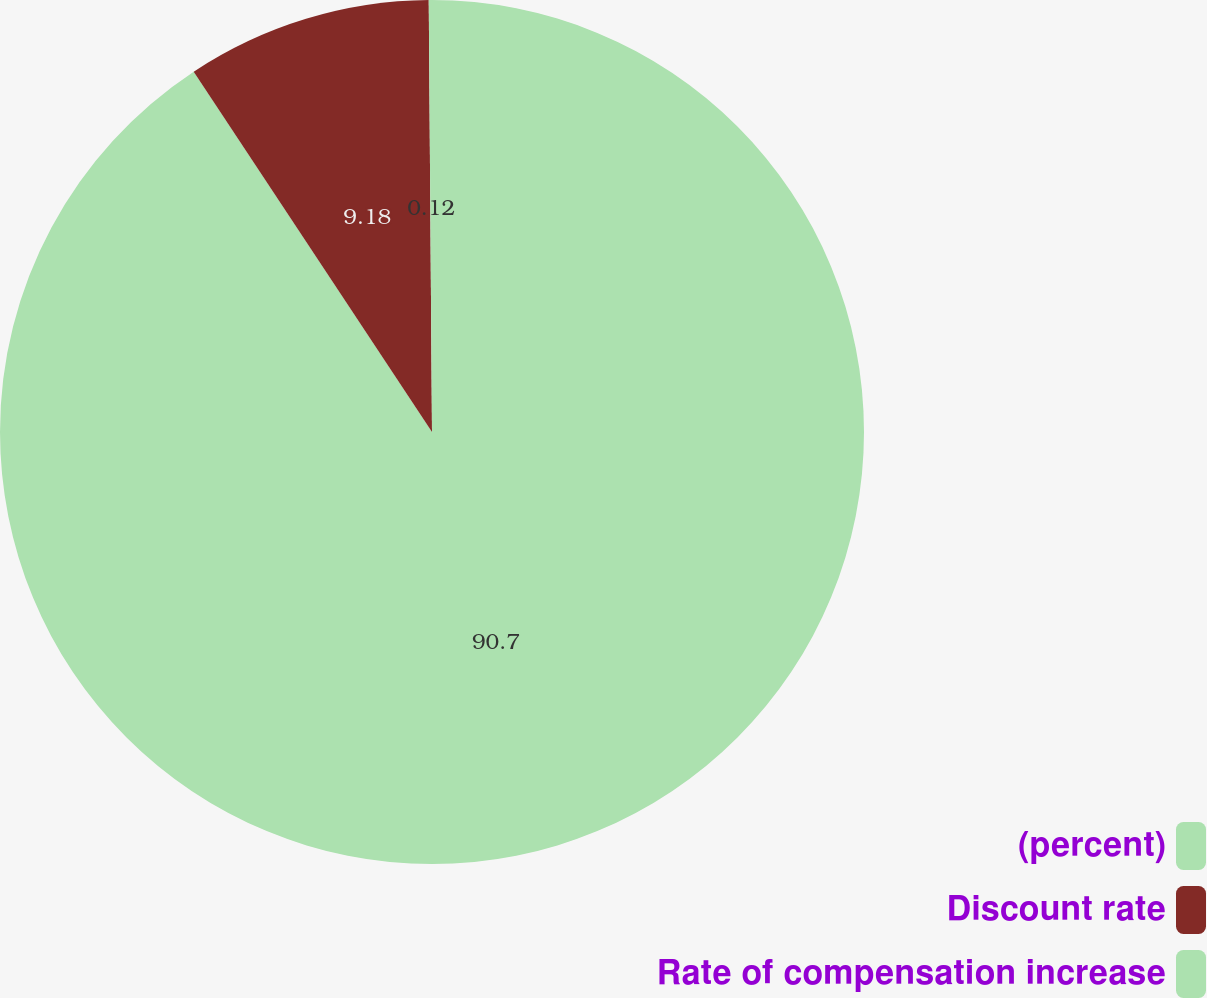Convert chart. <chart><loc_0><loc_0><loc_500><loc_500><pie_chart><fcel>(percent)<fcel>Discount rate<fcel>Rate of compensation increase<nl><fcel>90.7%<fcel>9.18%<fcel>0.12%<nl></chart> 